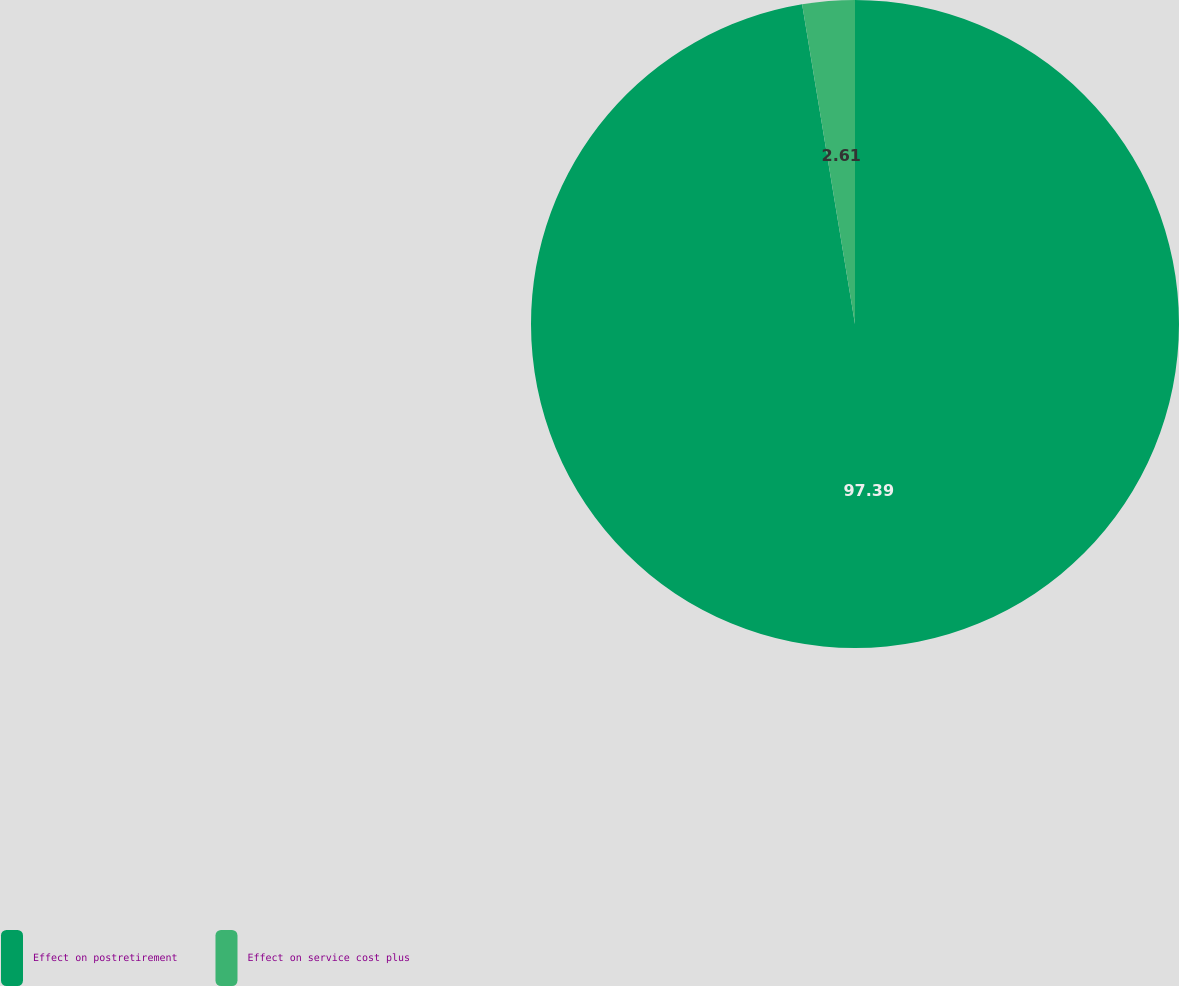Convert chart to OTSL. <chart><loc_0><loc_0><loc_500><loc_500><pie_chart><fcel>Effect on postretirement<fcel>Effect on service cost plus<nl><fcel>97.39%<fcel>2.61%<nl></chart> 